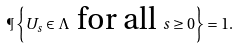Convert formula to latex. <formula><loc_0><loc_0><loc_500><loc_500>\P \left \{ U _ { s } \in \Lambda \text { for all } s \geq 0 \right \} = 1 .</formula> 